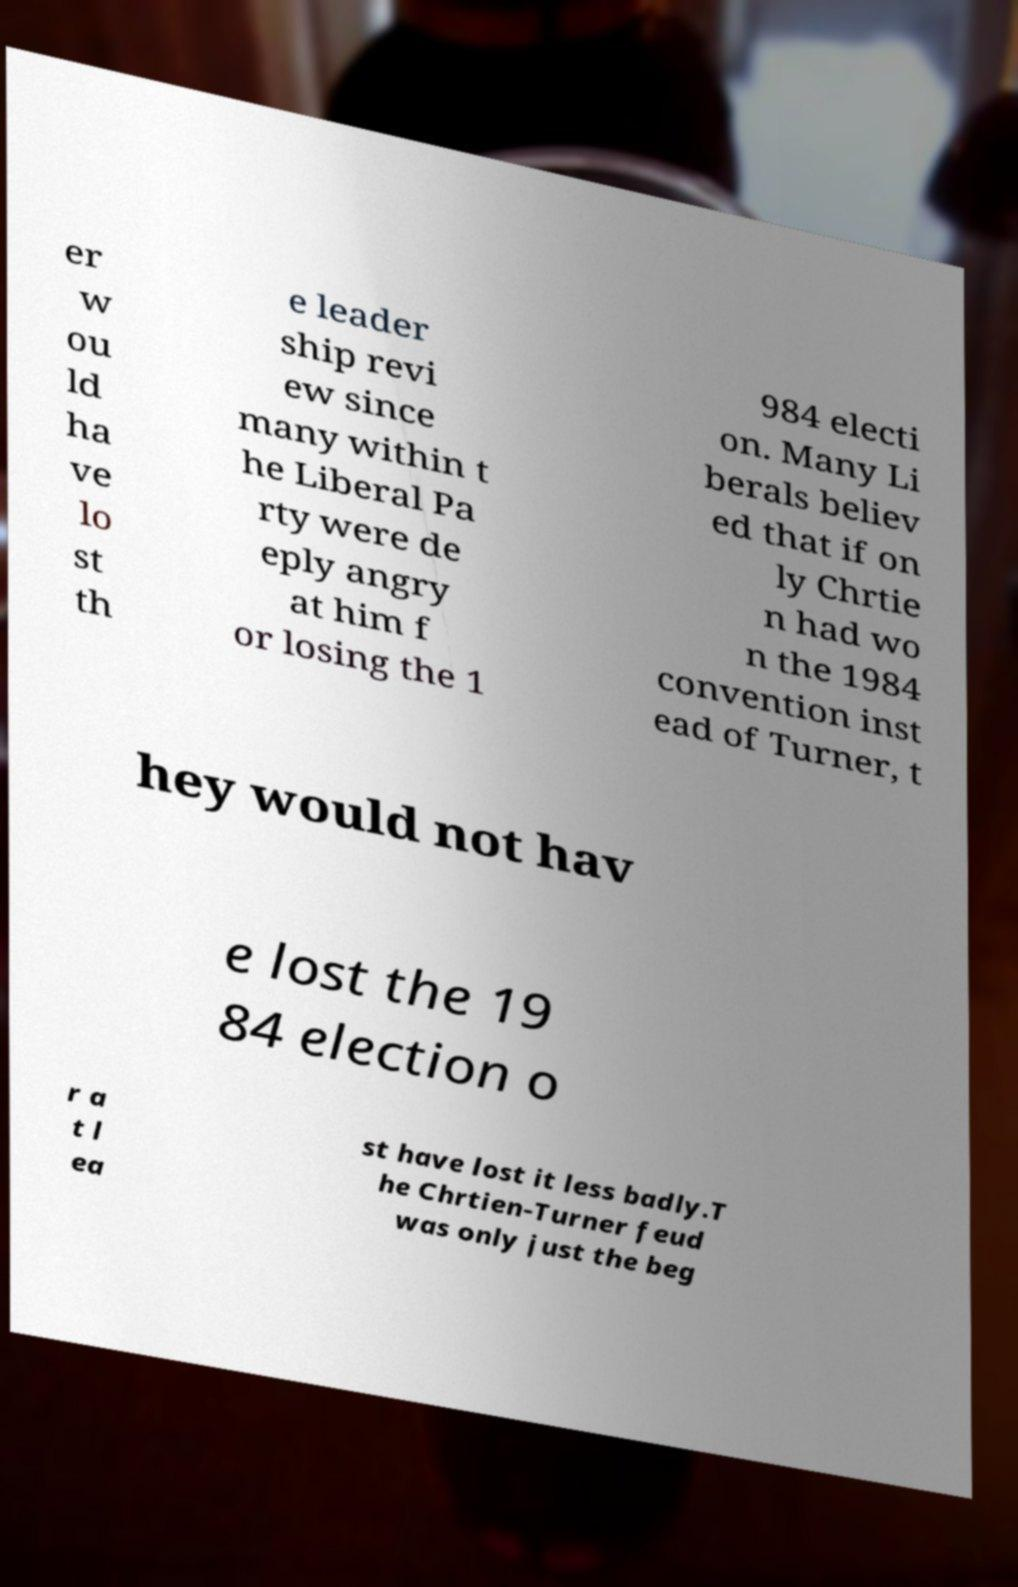Please identify and transcribe the text found in this image. er w ou ld ha ve lo st th e leader ship revi ew since many within t he Liberal Pa rty were de eply angry at him f or losing the 1 984 electi on. Many Li berals believ ed that if on ly Chrtie n had wo n the 1984 convention inst ead of Turner, t hey would not hav e lost the 19 84 election o r a t l ea st have lost it less badly.T he Chrtien-Turner feud was only just the beg 